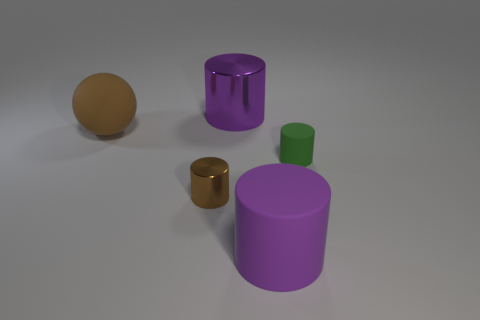Subtract 1 cylinders. How many cylinders are left? 3 Add 2 brown things. How many objects exist? 7 Subtract all cylinders. How many objects are left? 1 Subtract 0 cyan blocks. How many objects are left? 5 Subtract all big metal things. Subtract all big rubber cylinders. How many objects are left? 3 Add 5 small rubber things. How many small rubber things are left? 6 Add 1 large matte cylinders. How many large matte cylinders exist? 2 